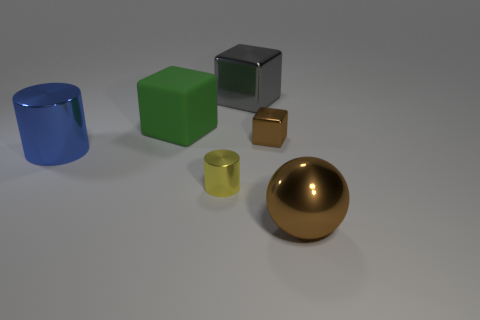Add 3 small yellow shiny things. How many objects exist? 9 Subtract all cylinders. How many objects are left? 4 Add 1 large brown metallic things. How many large brown metallic things exist? 2 Subtract 1 yellow cylinders. How many objects are left? 5 Subtract all cubes. Subtract all blue metal cylinders. How many objects are left? 2 Add 2 gray metal blocks. How many gray metal blocks are left? 3 